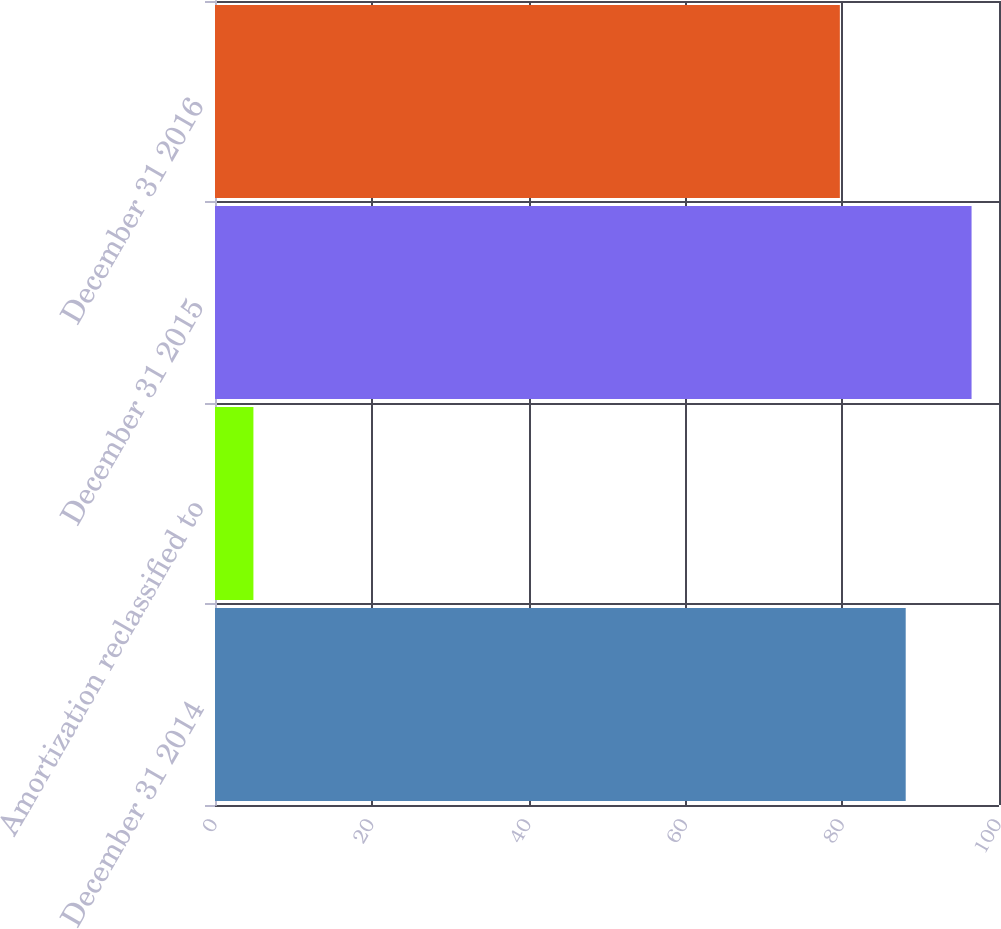Convert chart to OTSL. <chart><loc_0><loc_0><loc_500><loc_500><bar_chart><fcel>December 31 2014<fcel>Amortization reclassified to<fcel>December 31 2015<fcel>December 31 2016<nl><fcel>88.1<fcel>4.9<fcel>96.5<fcel>79.7<nl></chart> 